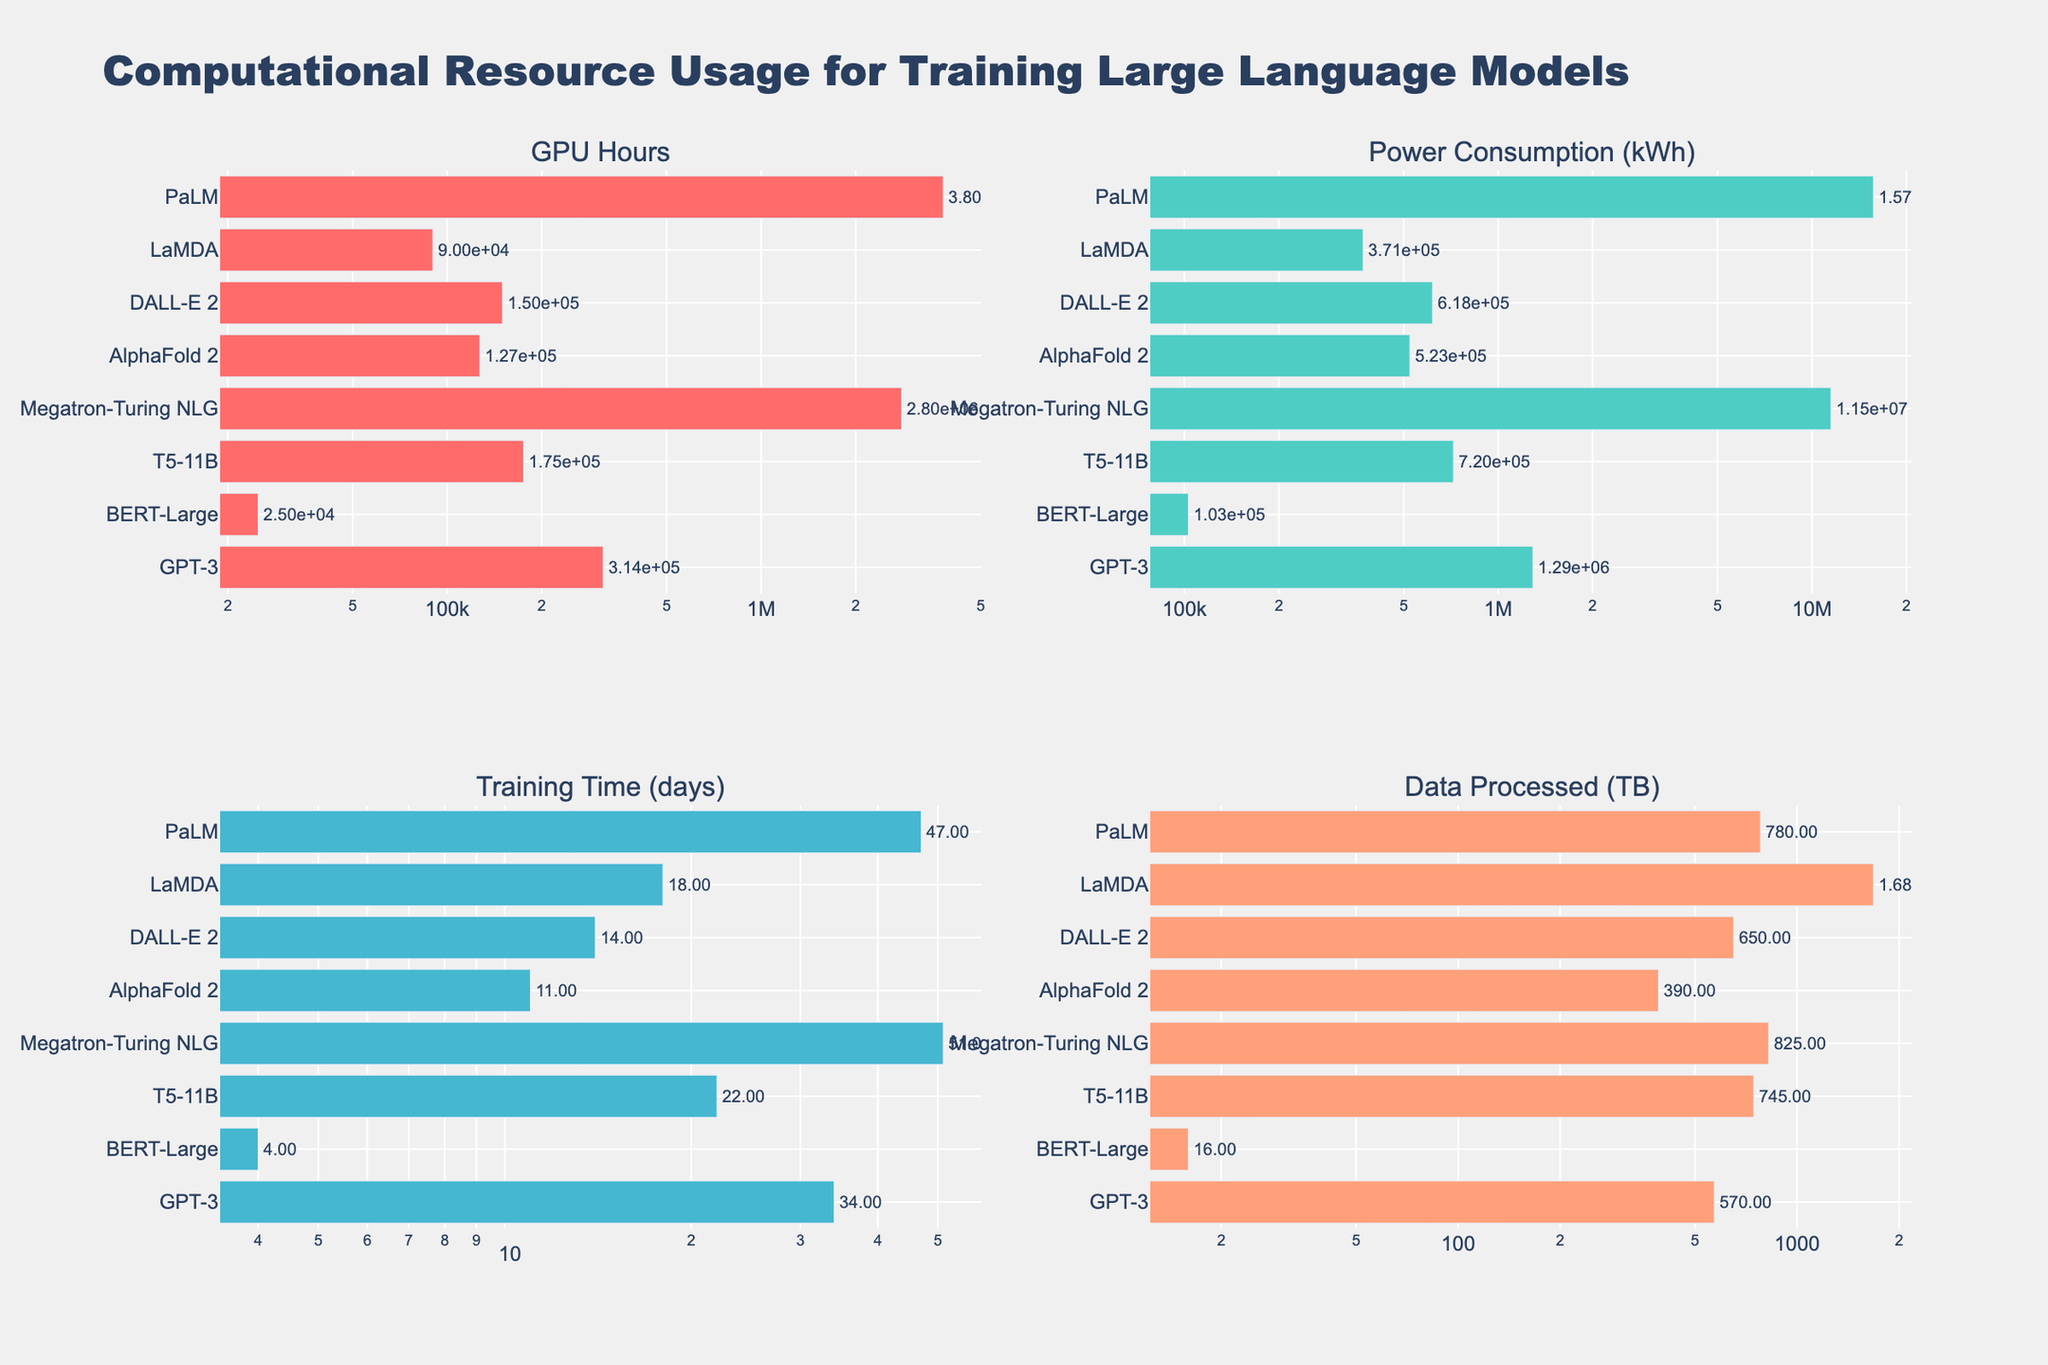What's the title of the figure? The title is located at the top of the figure. It reads "Computational Resource Usage for Training Large Language Models" in large, bold font.
Answer: Computational Resource Usage for Training Large Language Models How many models are compared in the figure? Count the number of bars in any subplot since each bar represents a different model. There are eight bars in each subplot.
Answer: Eight models Which model required the highest GPU Hours for training? Look at the "GPU Hours" subplot and identify the longest bar. "PaLM" has the longest bar in this subplot.
Answer: PaLM What's the training time (days) for AlphaFold 2? Check the "Training Time (days)" subplot and find the bar labeled "AlphaFold 2". The bar's label shows a value of 11.
Answer: 11 days Which model used the least power consumption (kWh)? Look at the "Power Consumption (kWh)" subplot and identify the shortest bar. "BERT-Large" has the shortest bar in this subplot.
Answer: BERT-Large Which models have a training time of more than one month? One month is approximately 30 days. Identify the bars in the "Training Time (days)" subplot that are greater than 30 days. "GPT-3," "Megatron-Turing NLG," and "PaLM" all have training times exceeding 30 days.
Answer: GPT-3, Megatron-Turing NLG, PaLM How much more data (TB) did LaMDA process than BERT-Large? In the "Data Processed (TB)" subplot, find LaMDA and BERT-Large bars and subtract the value of BERT-Large from LaMDA. LaMDA processed 1680 TB, and BERT-Large processed 16 TB. The difference is 1680 - 16 = 1664 TB.
Answer: 1664 TB What's the average power consumption (kWh) of GPT-3 and AlphaFold 2? Add the power consumption values for GPT-3 and AlphaFold 2 from the "Power Consumption (kWh)" subplot and divide by 2. GPT-3: 1.29e6 kWh, AlphaFold 2: 5.23e5 kWh. (1.29e6 + 5.23e5) / 2 = 9.055e5 kWh.
Answer: 9.055e5 kWh Which model has the closest GPU Hours to T5-11B? In the "GPU Hours" subplot, find the GPU Hours for T5-11B, which is 1.75e5. Compare it with other models and find the closest value. LaMDA has 9.0e4 GPU Hours, which is the closest to 1.75e5.
Answer: LaMDA What is the total training time (days) for GPT-3, BERT-Large, and T5-11B combined? Add the training time values for GPT-3, BERT-Large, and T5-11B from the "Training Time (days)" subplot. GPT-3: 34 days, BERT-Large: 4 days, T5-11B: 22 days. 34 + 4 + 22 = 60 days.
Answer: 60 days 